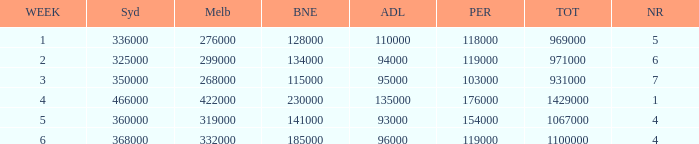What was the rating for Brisbane the week that Adelaide had 94000? 134000.0. 